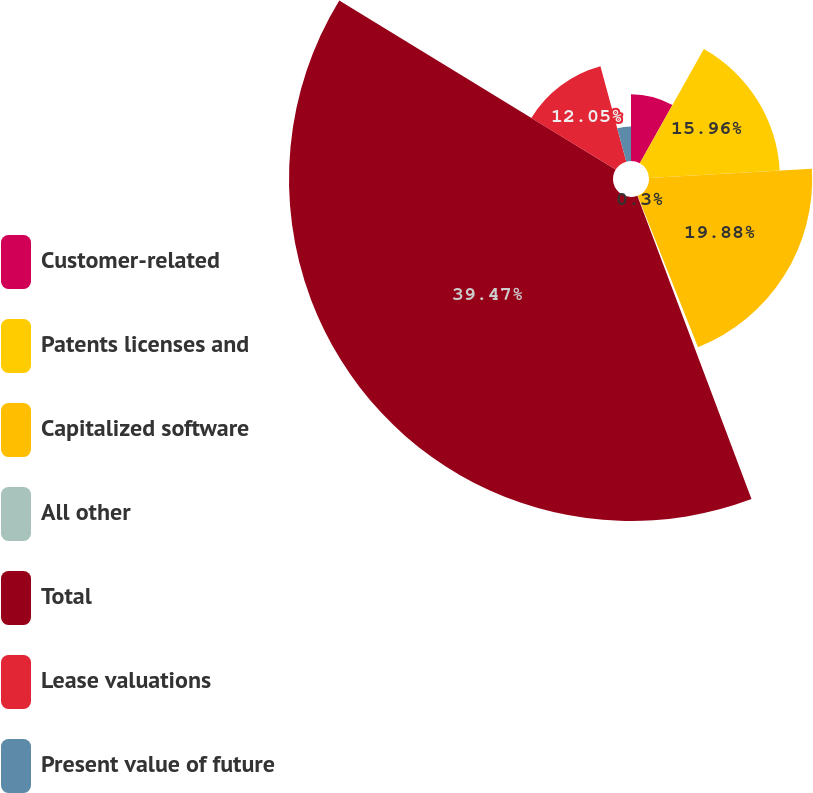Convert chart to OTSL. <chart><loc_0><loc_0><loc_500><loc_500><pie_chart><fcel>Customer-related<fcel>Patents licenses and<fcel>Capitalized software<fcel>All other<fcel>Total<fcel>Lease valuations<fcel>Present value of future<nl><fcel>8.13%<fcel>15.96%<fcel>19.88%<fcel>0.3%<fcel>39.47%<fcel>12.05%<fcel>4.21%<nl></chart> 